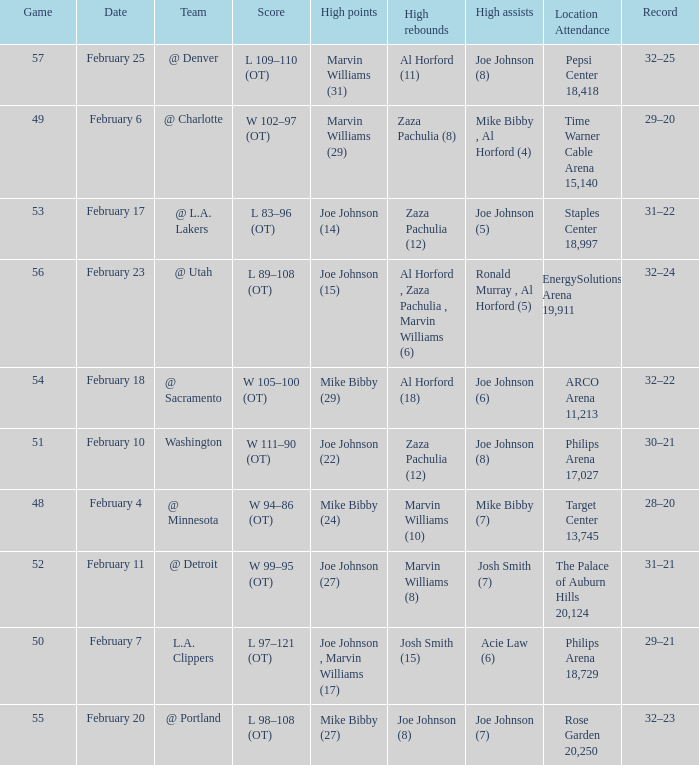Who made high assists on february 4 Mike Bibby (7). 